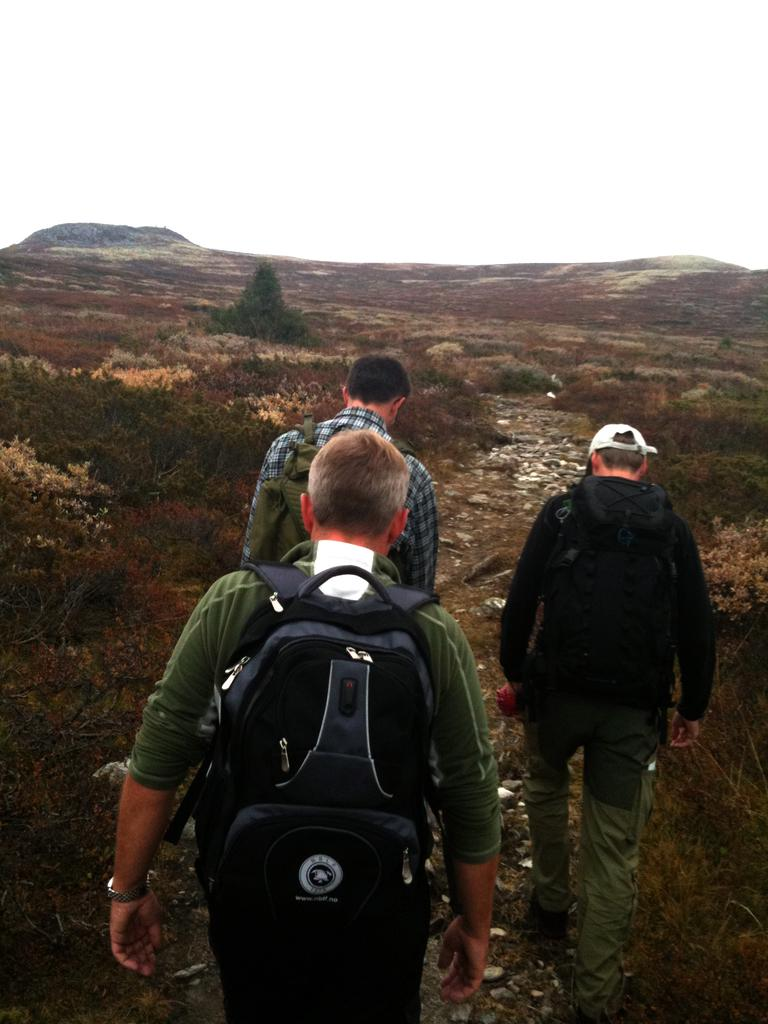How many men are present in the image? There are three men in the image. What are the men carrying on their backs? The men are carrying backpacks. What activity are the men engaged in? The men are walking on a path. What type of location is depicted in the image? The location appears to be a mountain area. What can be observed about the vegetation in the mountain area? The mountain area is filled with many shrubs. What is visible in the background of the image? The sky is visible in the background of the image. What type of doll can be seen in the hands of one of the men in the image? There is no doll present in the image; the men are carrying backpacks and walking on a path. 